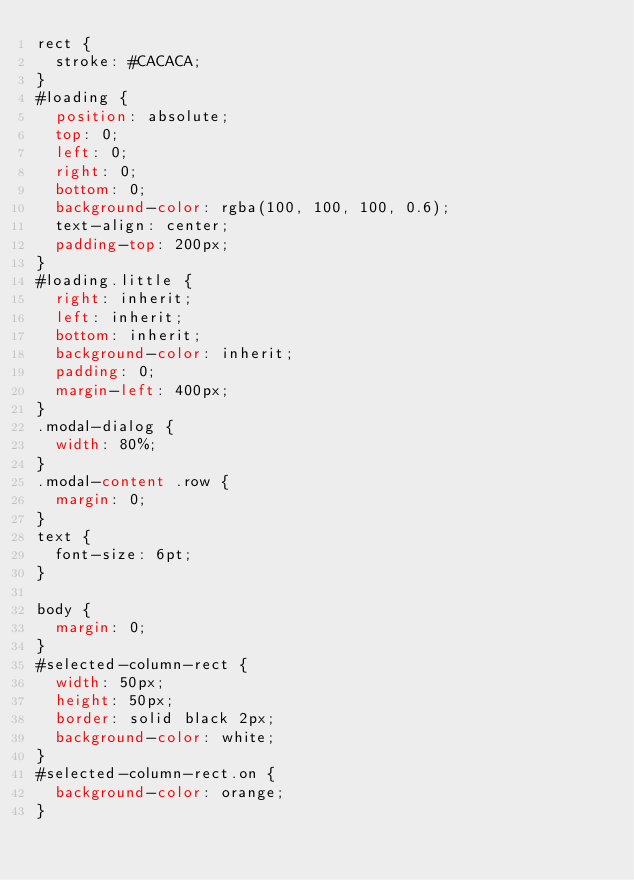Convert code to text. <code><loc_0><loc_0><loc_500><loc_500><_CSS_>rect {
  stroke: #CACACA;
}
#loading {
  position: absolute;
  top: 0;
  left: 0;
  right: 0;
  bottom: 0;
  background-color: rgba(100, 100, 100, 0.6);
  text-align: center;
  padding-top: 200px;
}
#loading.little {
  right: inherit;
  left: inherit;
  bottom: inherit;
  background-color: inherit;
  padding: 0;
  margin-left: 400px;
}
.modal-dialog {
  width: 80%;
}
.modal-content .row {
  margin: 0;
}
text {
  font-size: 6pt;
}

body {
  margin: 0;
}
#selected-column-rect {
  width: 50px;
  height: 50px;
  border: solid black 2px;
  background-color: white;
}
#selected-column-rect.on {
  background-color: orange;
}
</code> 